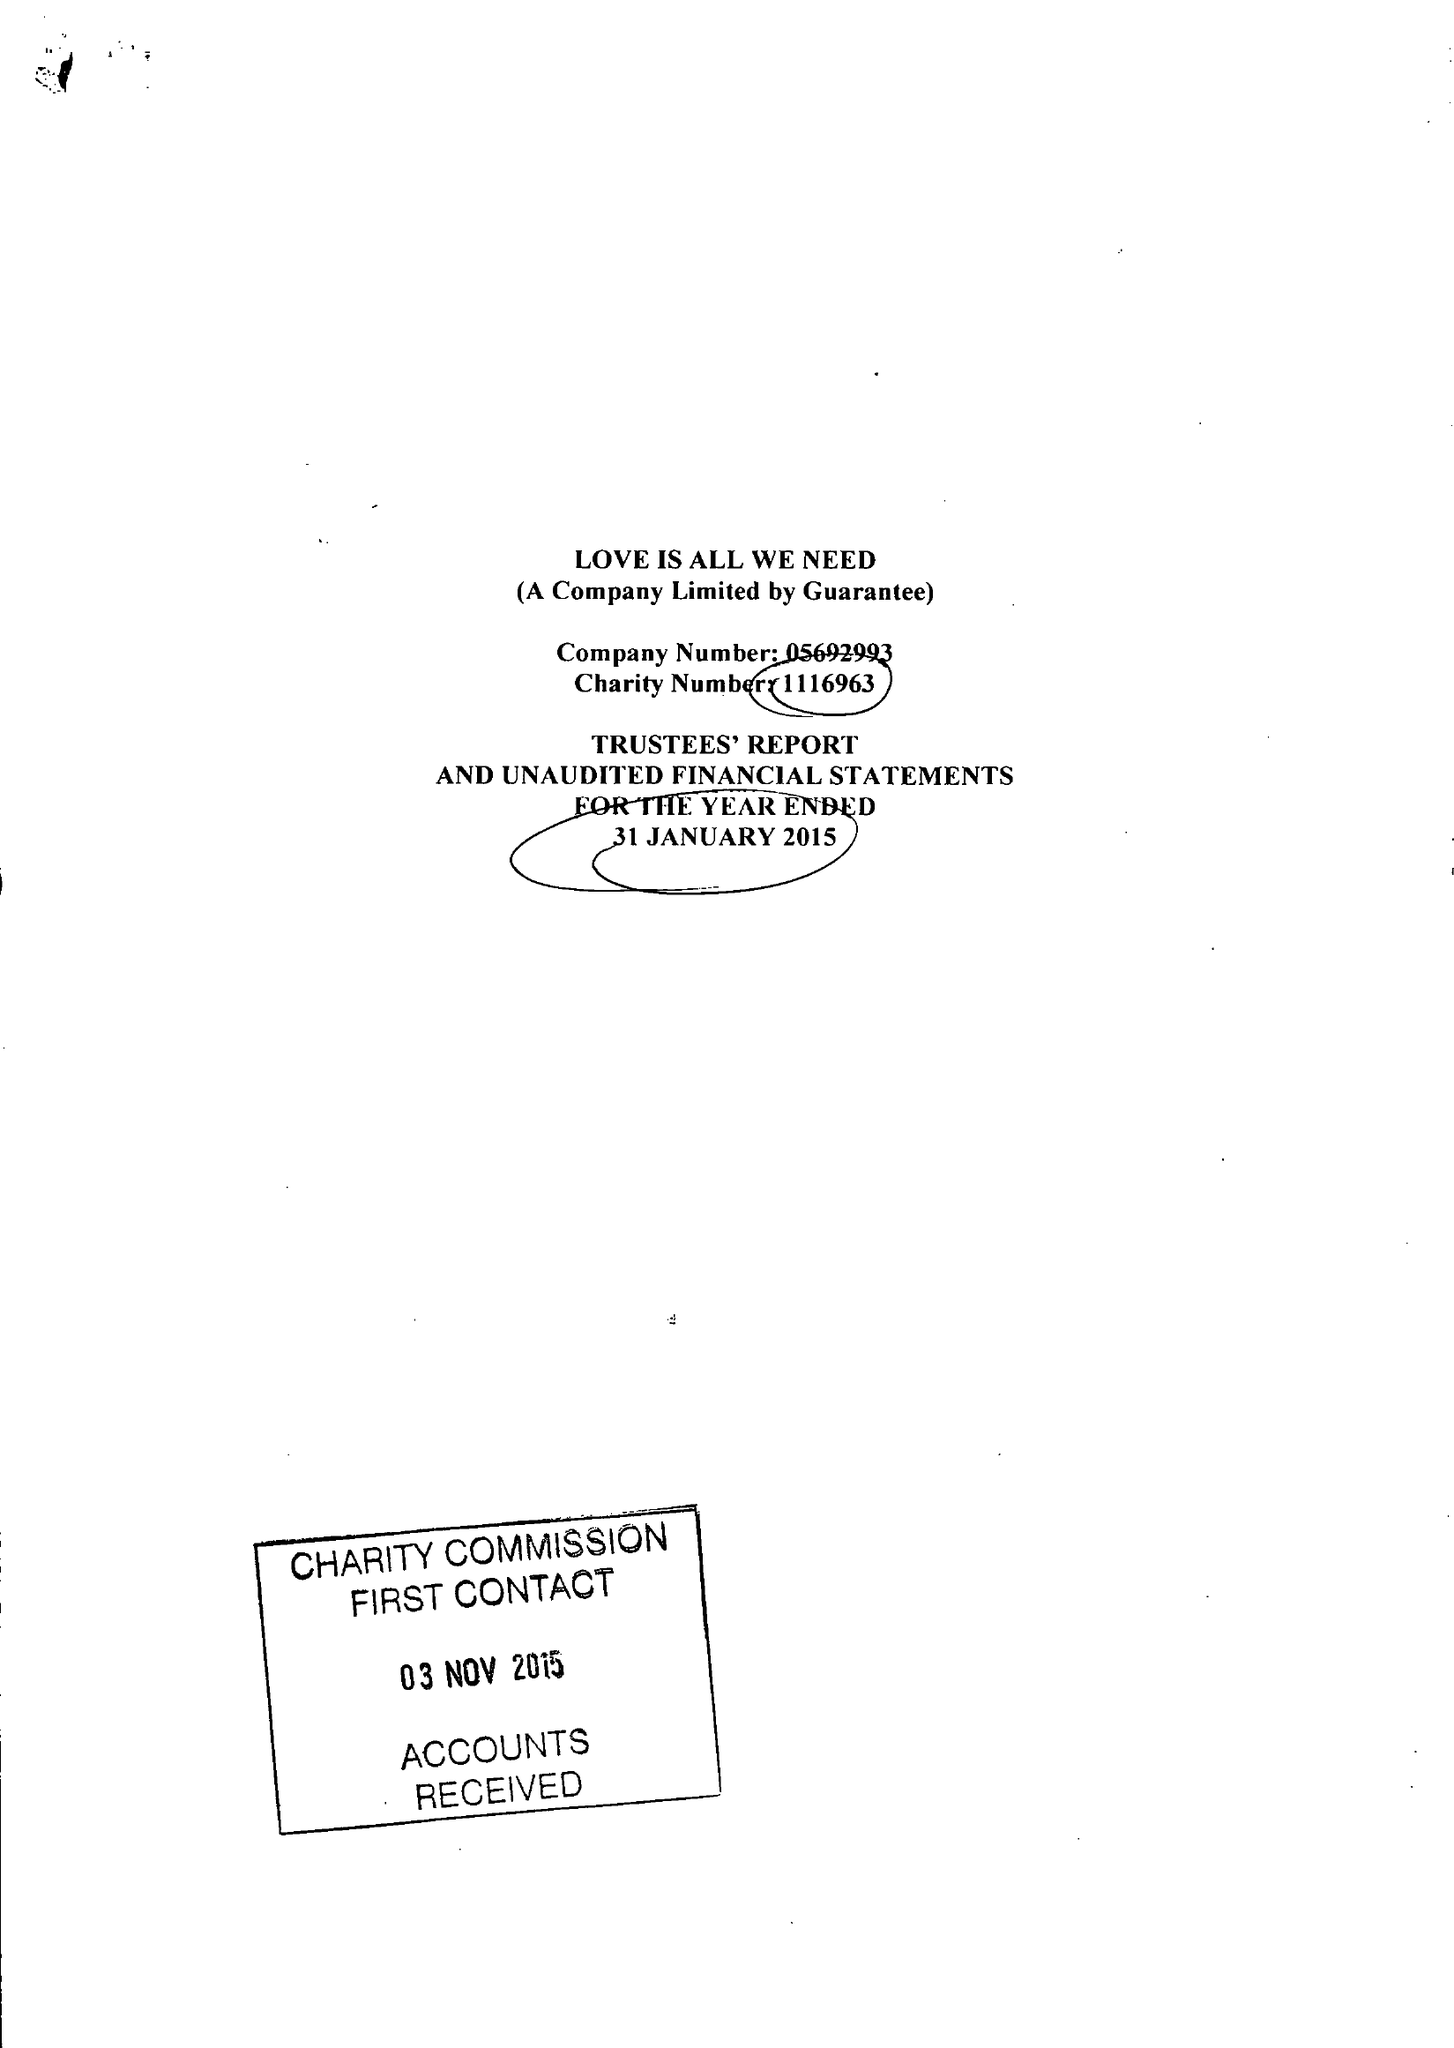What is the value for the report_date?
Answer the question using a single word or phrase. 2015-01-31 